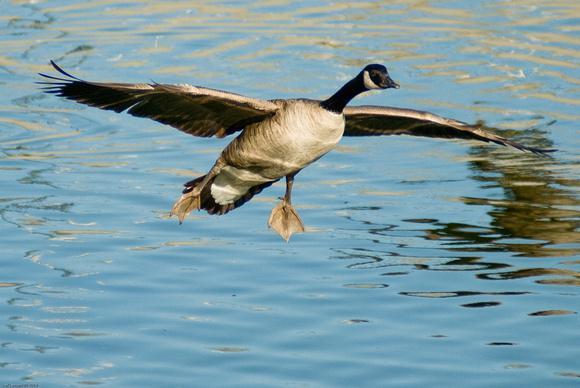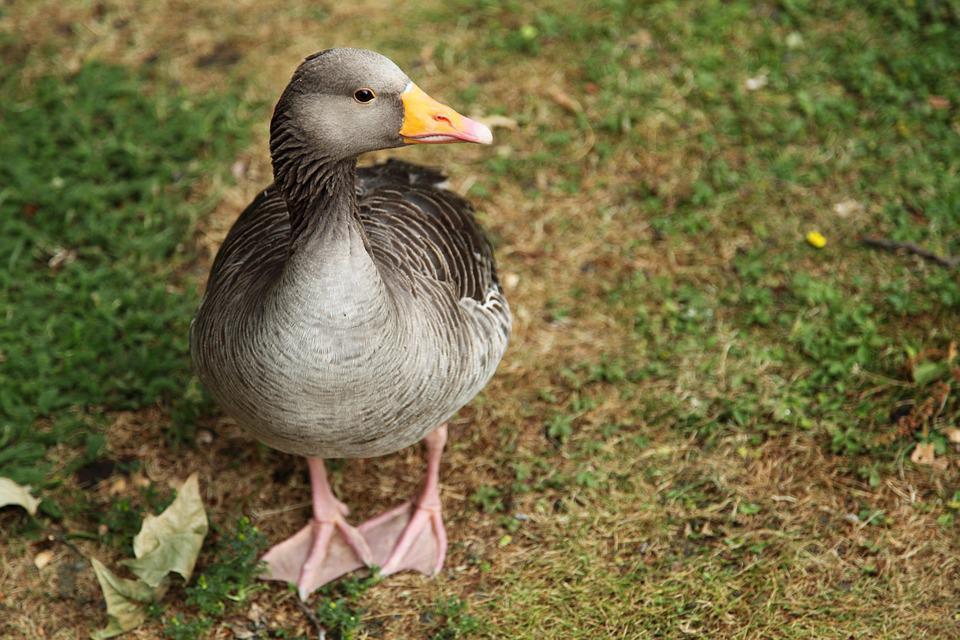The first image is the image on the left, the second image is the image on the right. Examine the images to the left and right. Is the description "There are two geese" accurate? Answer yes or no. Yes. 